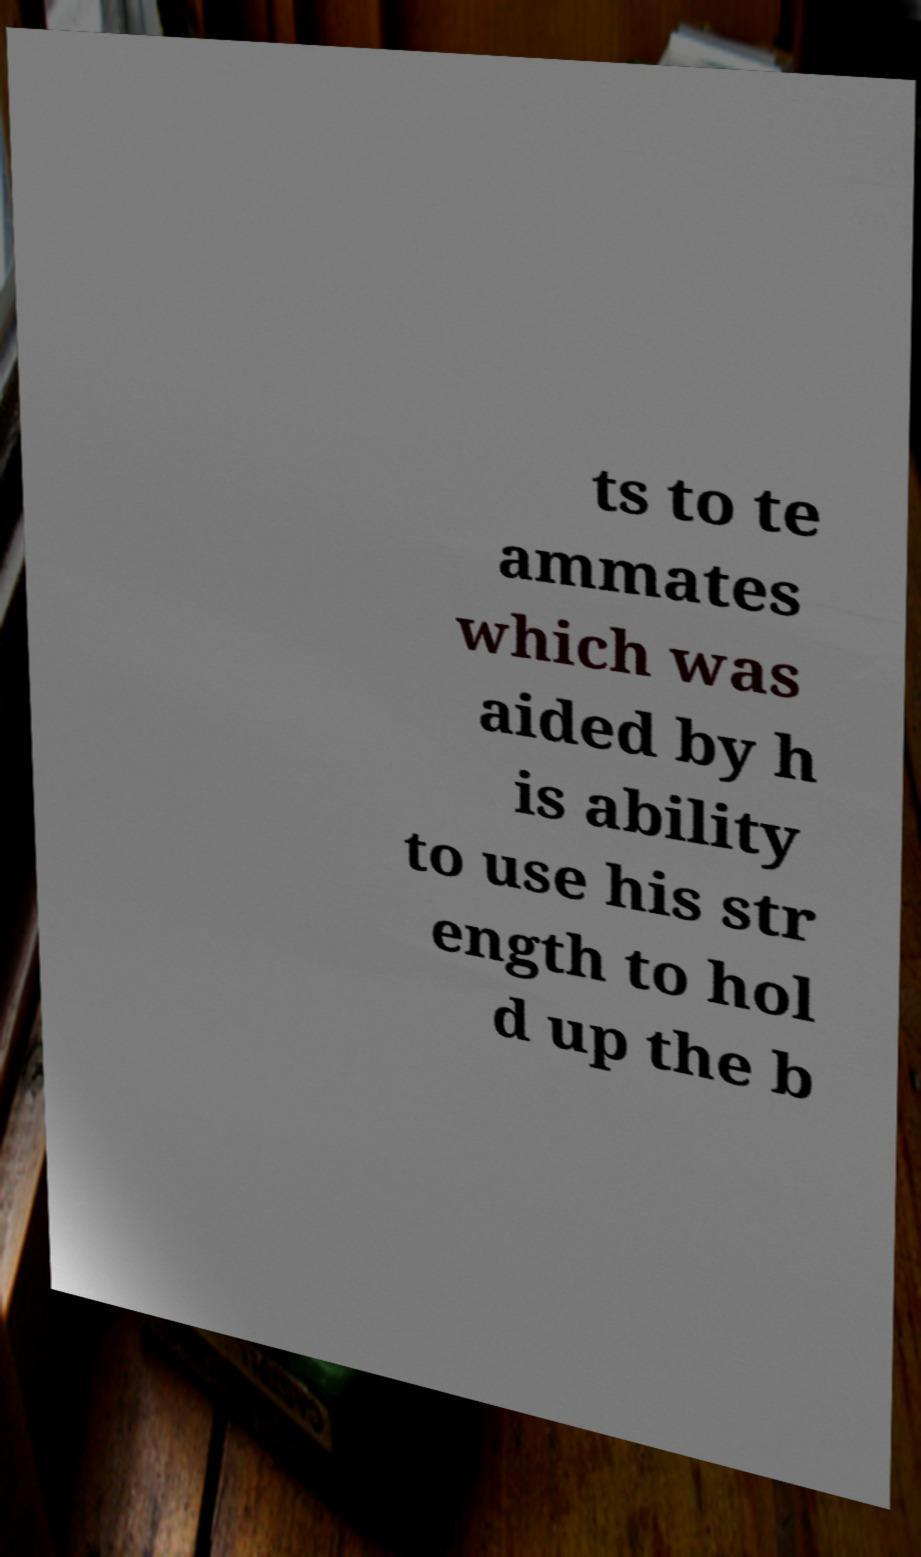For documentation purposes, I need the text within this image transcribed. Could you provide that? ts to te ammates which was aided by h is ability to use his str ength to hol d up the b 